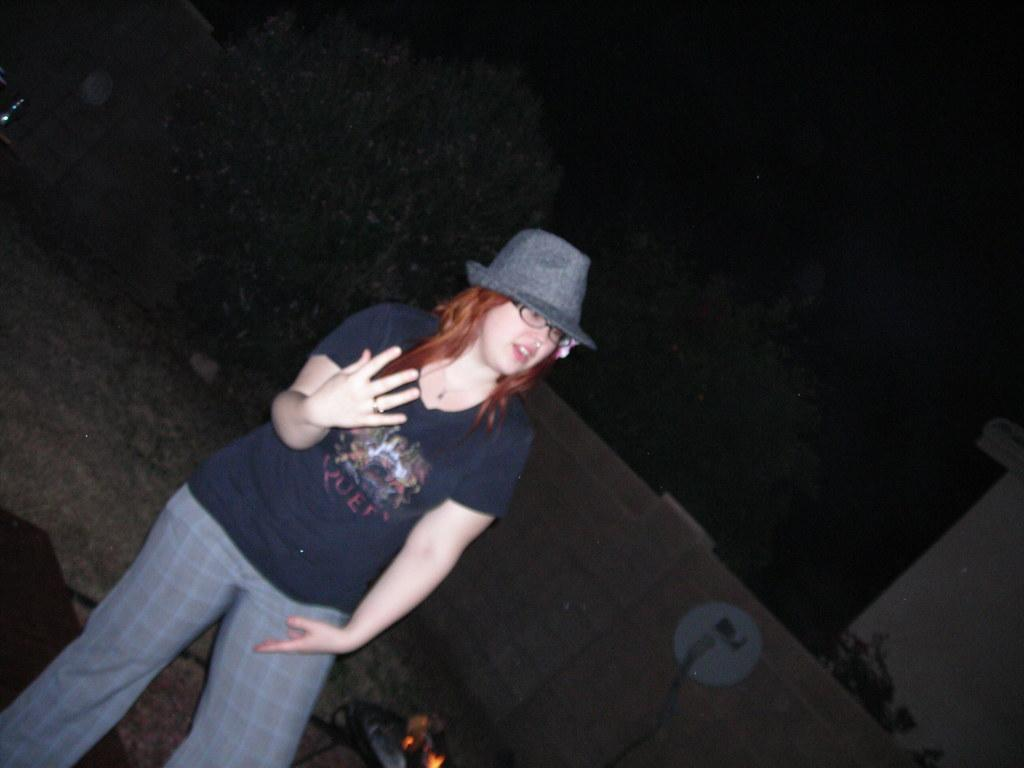Who is present in the image? There is a woman in the image. What is the woman wearing on her face? The woman is wearing spectacles. What can be seen in the image that is related to heat or fire? There is a flame in the image. What is the background of the image made of? There is a wall in the image. What type of vegetation is visible in the background? There are plants in the background of the image. What type of chalk is the queen using to draw on the suit in the image? There is no chalk, queen, or suit present in the image. 